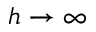Convert formula to latex. <formula><loc_0><loc_0><loc_500><loc_500>h \to \infty</formula> 